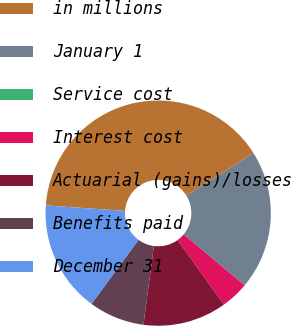Convert chart. <chart><loc_0><loc_0><loc_500><loc_500><pie_chart><fcel>in millions<fcel>January 1<fcel>Service cost<fcel>Interest cost<fcel>Actuarial (gains)/losses<fcel>Benefits paid<fcel>December 31<nl><fcel>39.98%<fcel>20.0%<fcel>0.01%<fcel>4.01%<fcel>12.0%<fcel>8.0%<fcel>16.0%<nl></chart> 